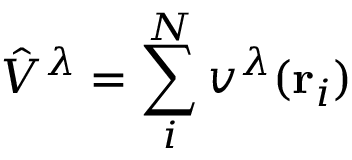Convert formula to latex. <formula><loc_0><loc_0><loc_500><loc_500>\hat { V } ^ { \lambda } = \sum _ { i } ^ { N } v ^ { \lambda } ( r _ { i } )</formula> 